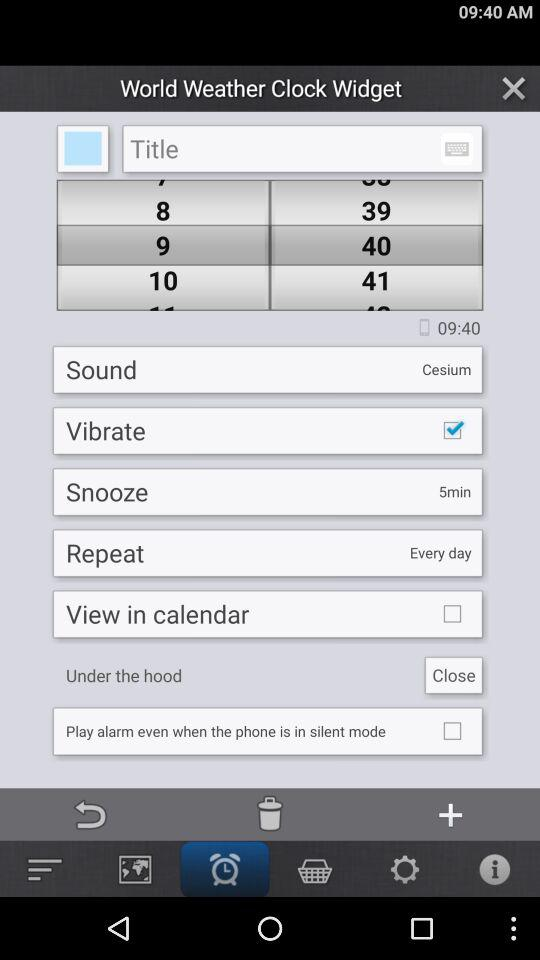Which sound is selected? The selected sound is "Cesium". 